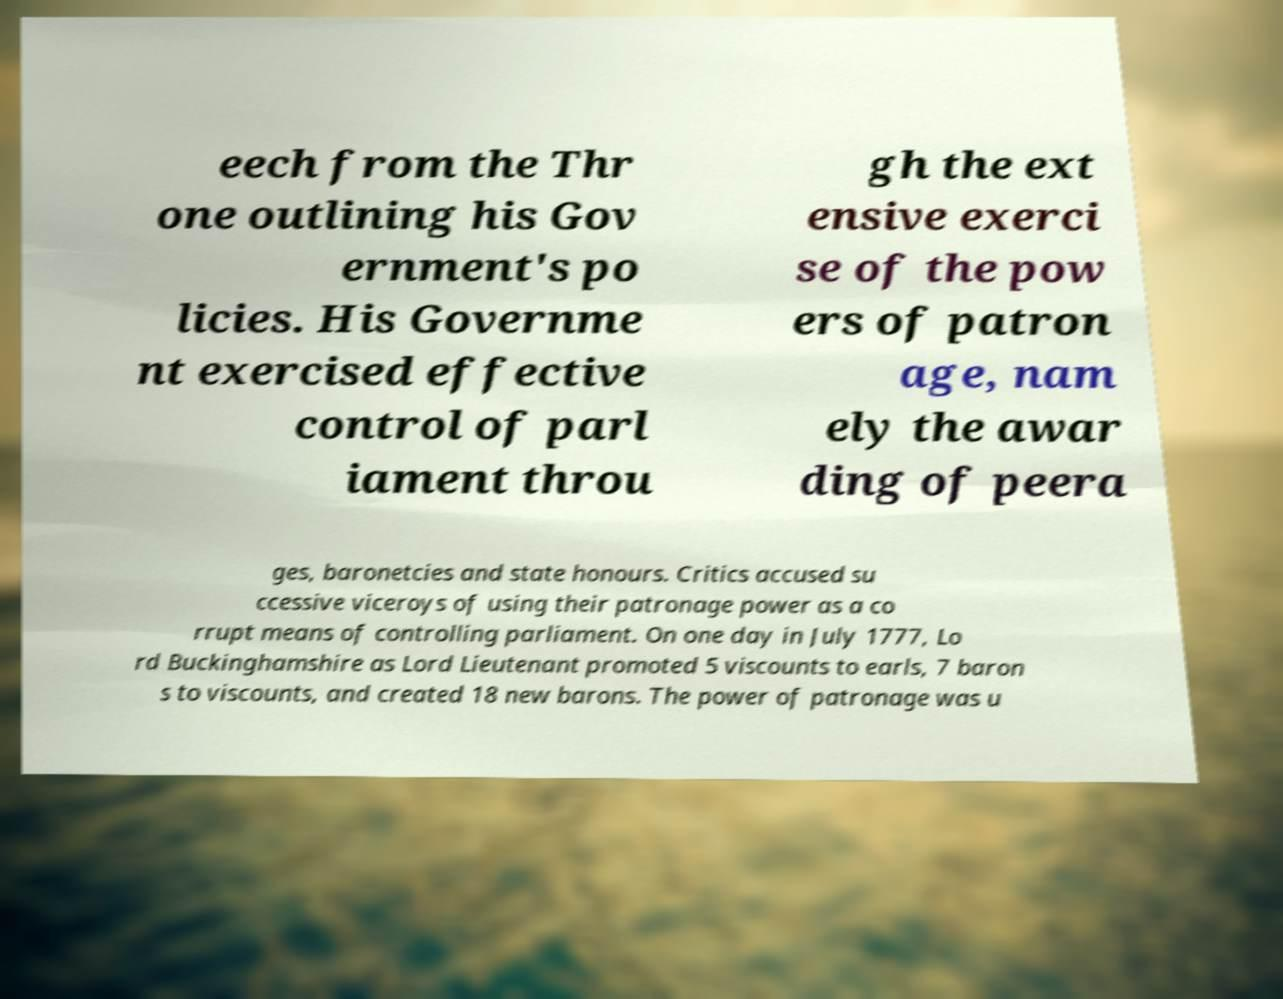Can you accurately transcribe the text from the provided image for me? eech from the Thr one outlining his Gov ernment's po licies. His Governme nt exercised effective control of parl iament throu gh the ext ensive exerci se of the pow ers of patron age, nam ely the awar ding of peera ges, baronetcies and state honours. Critics accused su ccessive viceroys of using their patronage power as a co rrupt means of controlling parliament. On one day in July 1777, Lo rd Buckinghamshire as Lord Lieutenant promoted 5 viscounts to earls, 7 baron s to viscounts, and created 18 new barons. The power of patronage was u 